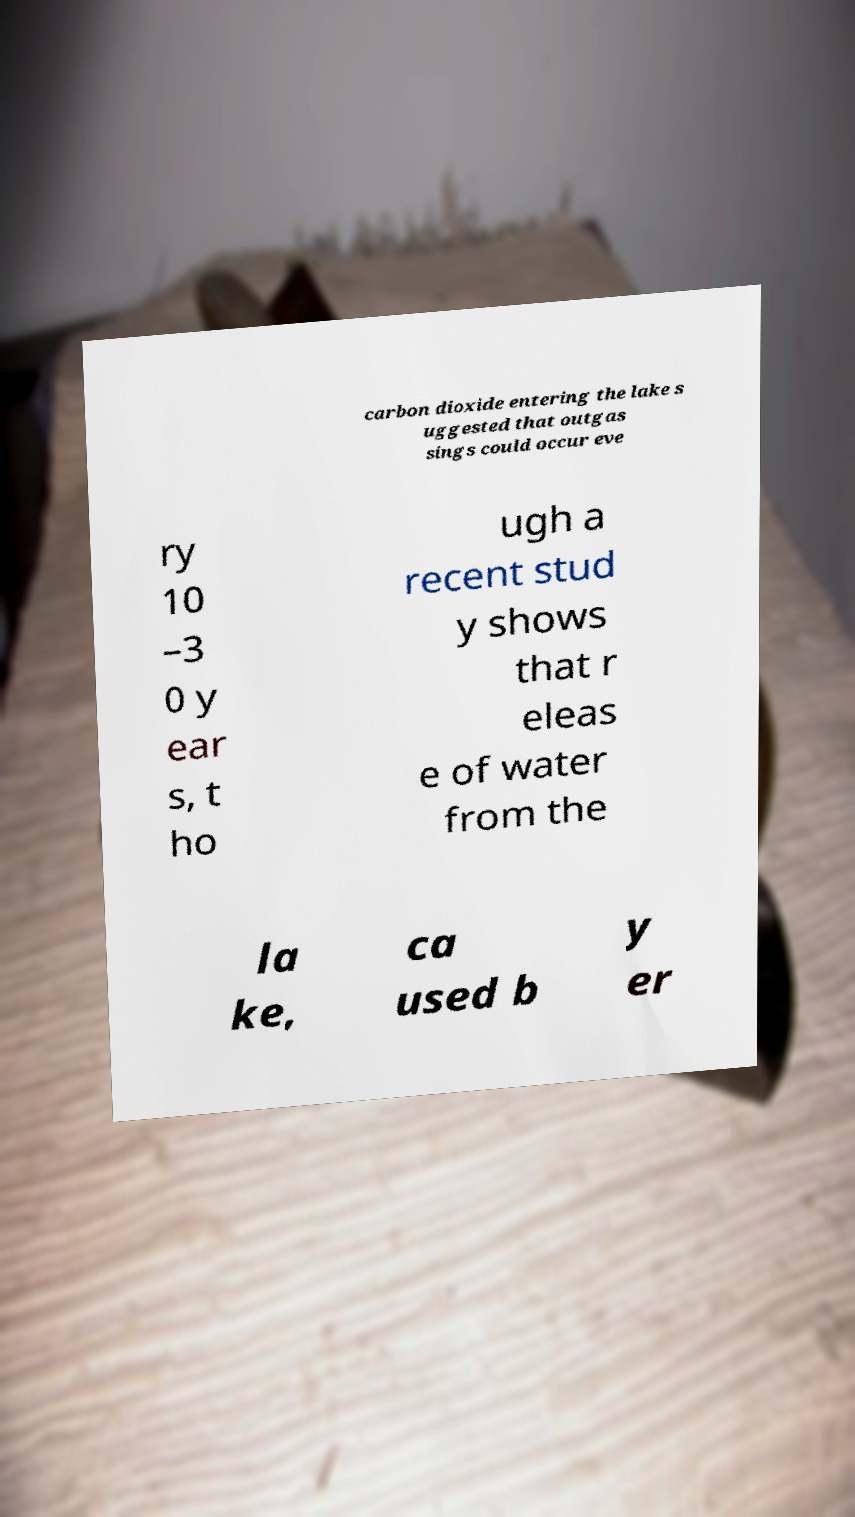What messages or text are displayed in this image? I need them in a readable, typed format. carbon dioxide entering the lake s uggested that outgas sings could occur eve ry 10 –3 0 y ear s, t ho ugh a recent stud y shows that r eleas e of water from the la ke, ca used b y er 